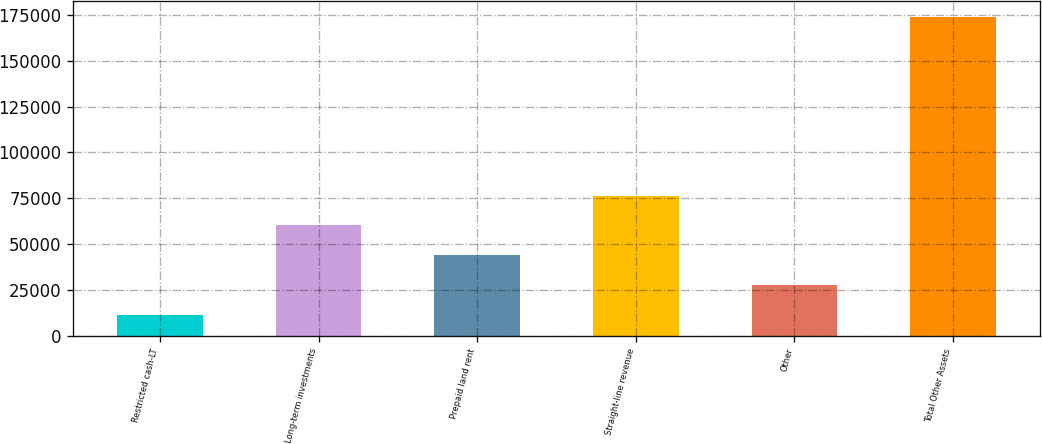Convert chart to OTSL. <chart><loc_0><loc_0><loc_500><loc_500><bar_chart><fcel>Restricted cash-LT<fcel>Long-term investments<fcel>Prepaid land rent<fcel>Straight-line revenue<fcel>Other<fcel>Total Other Assets<nl><fcel>11392<fcel>60176.8<fcel>43915.2<fcel>76438.4<fcel>27653.6<fcel>174008<nl></chart> 